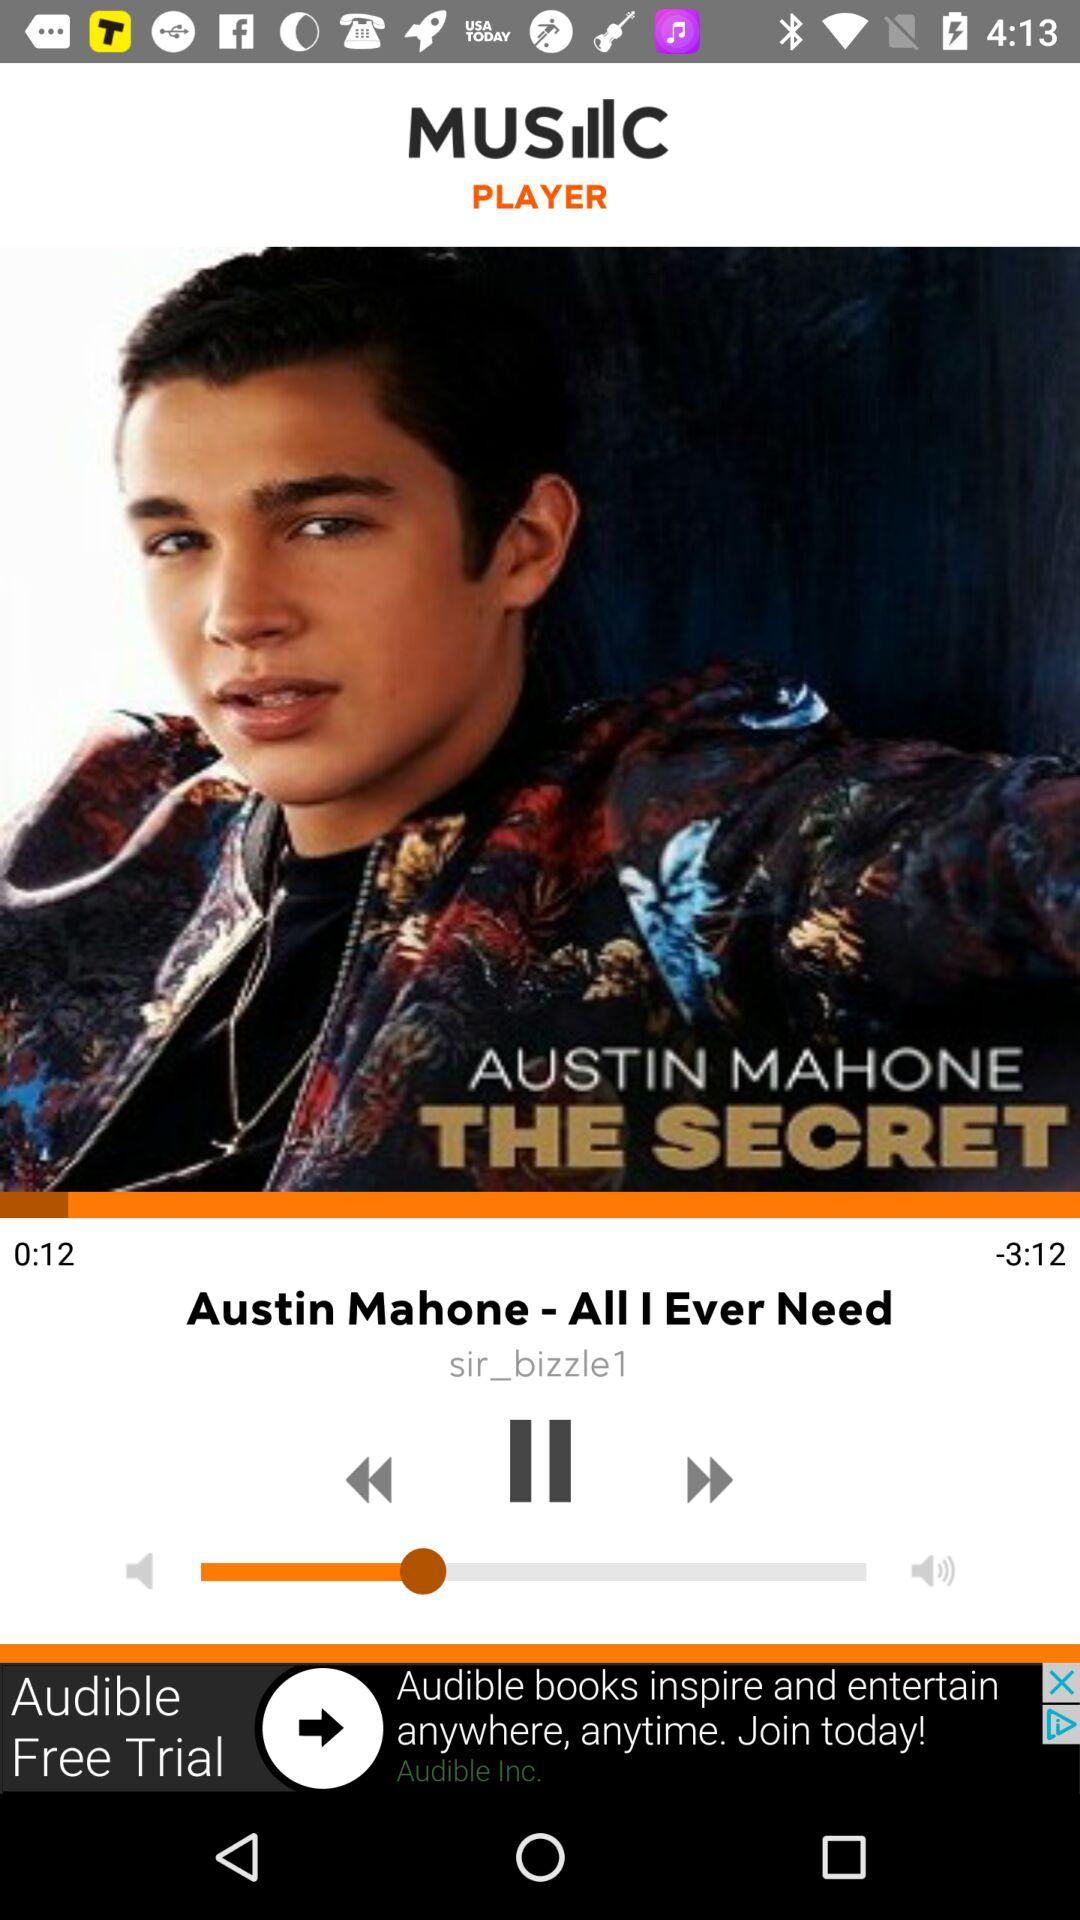How long audio is?
When the provided information is insufficient, respond with <no answer>. <no answer> 